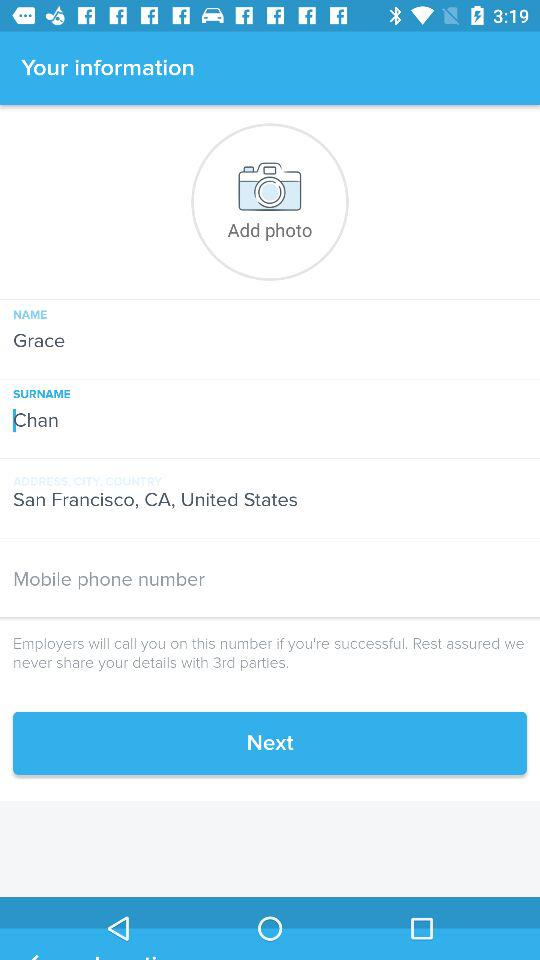With which parties will the employers never share the details? The employers will never share the details with 3rd parties. 